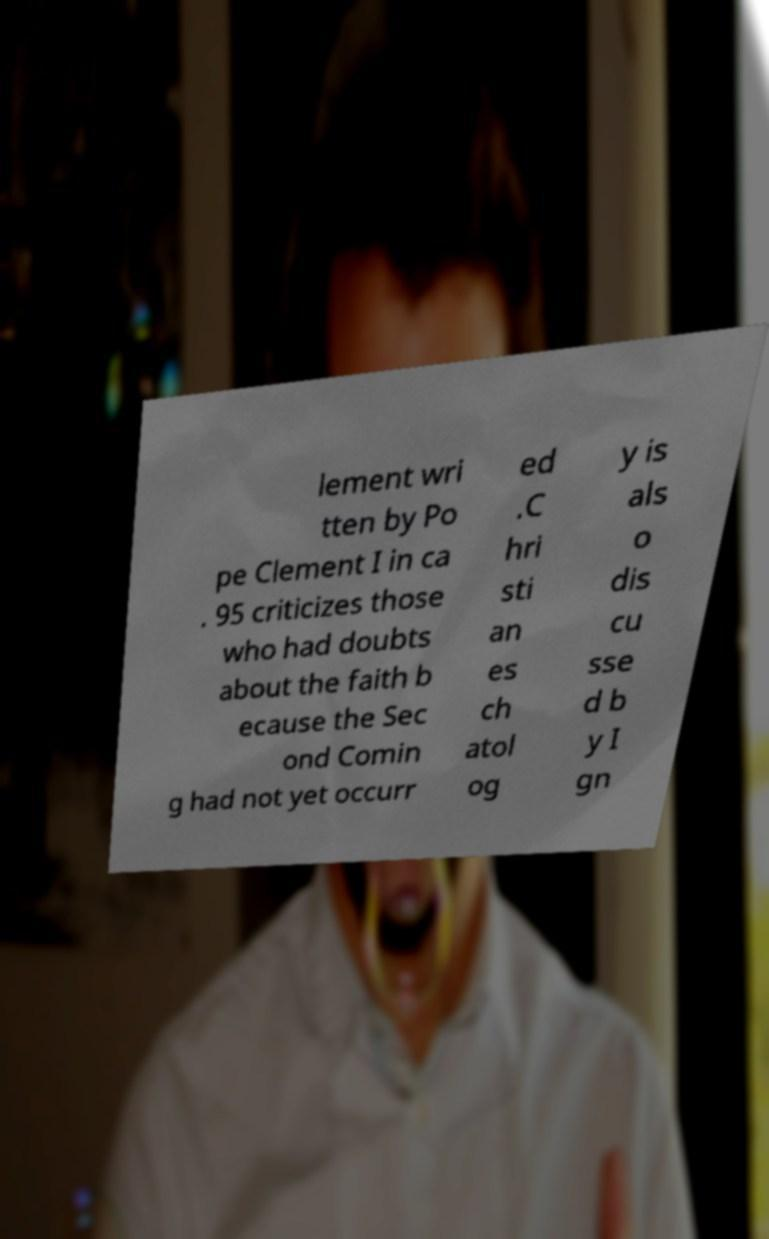For documentation purposes, I need the text within this image transcribed. Could you provide that? lement wri tten by Po pe Clement I in ca . 95 criticizes those who had doubts about the faith b ecause the Sec ond Comin g had not yet occurr ed .C hri sti an es ch atol og y is als o dis cu sse d b y I gn 